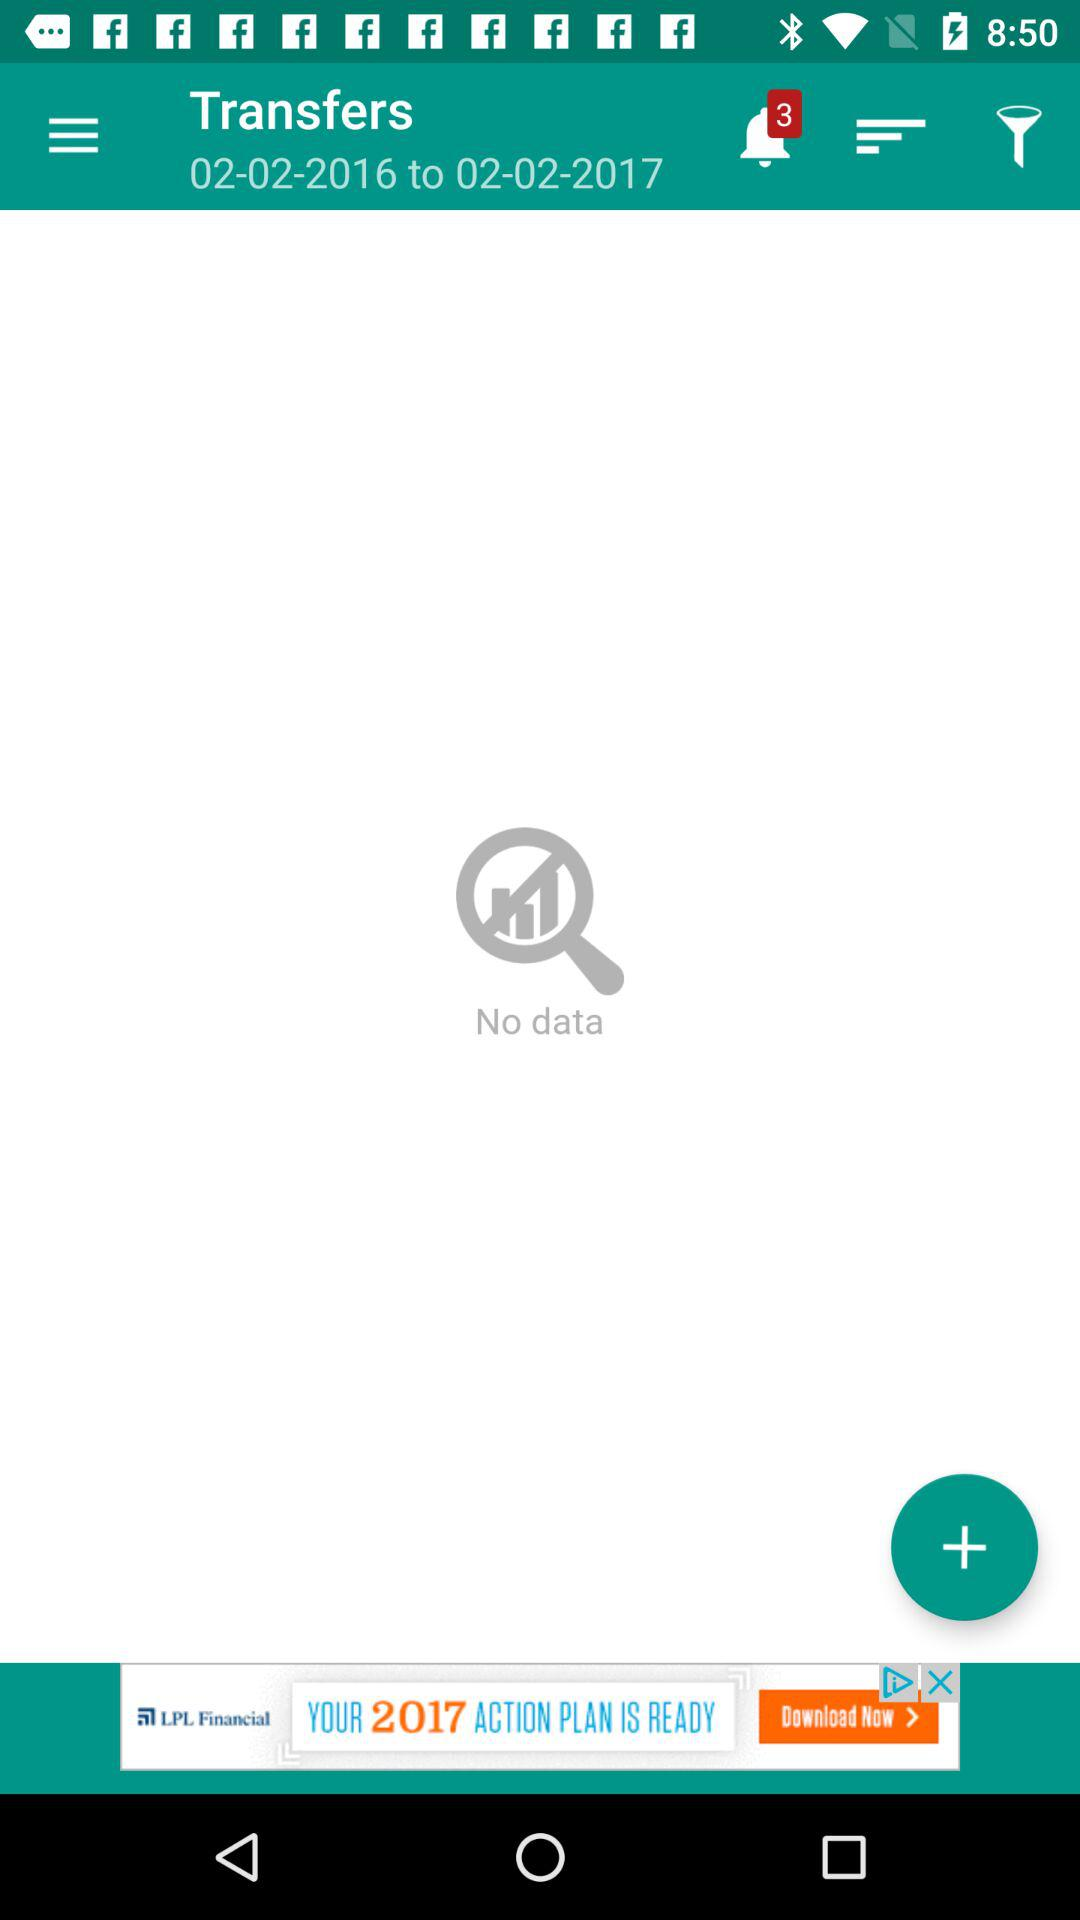How many notifications are shown? There are 3 notifications. 